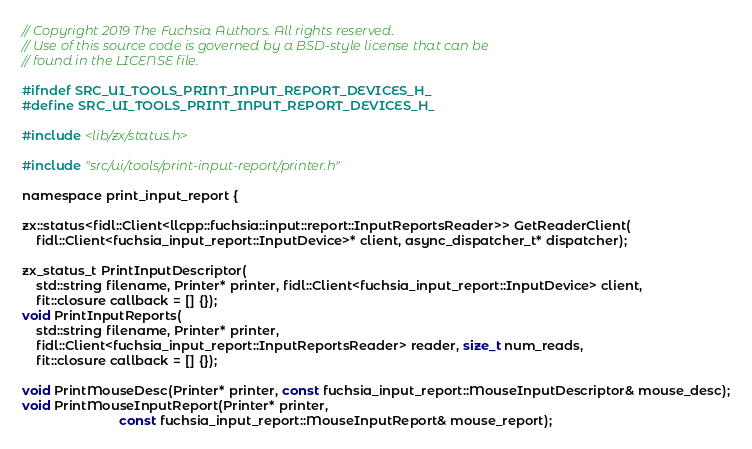Convert code to text. <code><loc_0><loc_0><loc_500><loc_500><_C_>// Copyright 2019 The Fuchsia Authors. All rights reserved.
// Use of this source code is governed by a BSD-style license that can be
// found in the LICENSE file.

#ifndef SRC_UI_TOOLS_PRINT_INPUT_REPORT_DEVICES_H_
#define SRC_UI_TOOLS_PRINT_INPUT_REPORT_DEVICES_H_

#include <lib/zx/status.h>

#include "src/ui/tools/print-input-report/printer.h"

namespace print_input_report {

zx::status<fidl::Client<llcpp::fuchsia::input::report::InputReportsReader>> GetReaderClient(
    fidl::Client<fuchsia_input_report::InputDevice>* client, async_dispatcher_t* dispatcher);

zx_status_t PrintInputDescriptor(
    std::string filename, Printer* printer, fidl::Client<fuchsia_input_report::InputDevice> client,
    fit::closure callback = [] {});
void PrintInputReports(
    std::string filename, Printer* printer,
    fidl::Client<fuchsia_input_report::InputReportsReader> reader, size_t num_reads,
    fit::closure callback = [] {});

void PrintMouseDesc(Printer* printer, const fuchsia_input_report::MouseInputDescriptor& mouse_desc);
void PrintMouseInputReport(Printer* printer,
                           const fuchsia_input_report::MouseInputReport& mouse_report);
</code> 